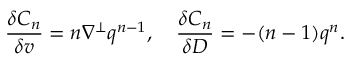<formula> <loc_0><loc_0><loc_500><loc_500>\frac { \delta C _ { n } } { \delta v } = n \nabla ^ { \perp } q ^ { n - 1 } , \quad \frac { \delta C _ { n } } { \delta D } = - ( n - 1 ) q ^ { n } .</formula> 